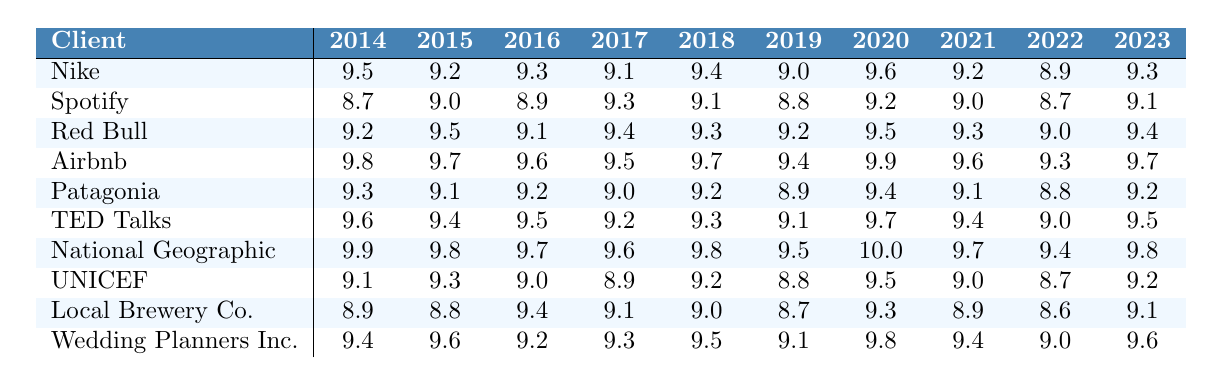What is the satisfaction rating of Nike in 2020? The table indicates that Nike's satisfaction rating for the year 2020 is 9.2, as listed in the corresponding row and column.
Answer: 9.2 What is the highest satisfaction rating recorded for National Geographic? The highest rating for National Geographic is 10.0, which can be found in the year 2019 column.
Answer: 10.0 Which client received the lowest satisfaction rating in 2015? By examining the ratings for each client in 2015, the lowest rating is 8.7, which corresponds to Spotify.
Answer: Spotify What is the average satisfaction rating of Airbnb across all years? To find the average, sum all the ratings for Airbnb (9.8 + 9.7 + 9.6 + 9.5 + 9.7 + 9.4 + 9.9 + 9.6 + 9.3 + 9.7 = 96.2) and divide by the total number of years (10). Thus, the average rating is 96.2 / 10 = 9.62.
Answer: 9.62 Did any client receive a satisfaction rating of 9.8 in 2022? Scanning through the table for the year 2022, there is no record of any client receiving a rating of 9.8; thus, the answer is no.
Answer: No Which client consistently had a satisfaction rating above 9.5 in the years 2016 and 2017? Looking at the ratings for 2016 (9.1 for Red Bull and 9.5 for Airbnb) and for 2017 (9.4 for Red Bull and 9.7 for Airbnb), we see that Airbnb is the only client that meets the criterion in both years.
Answer: Airbnb What is the difference between the highest satisfaction rating of TED Talks and the lowest in the same year? TED Talks' highest rating occurred in 2016 at 9.5, while the lowest rating was 8.8 in 2015. The difference between 9.5 and 8.8 is 0.7.
Answer: 0.7 Which client had the highest satisfaction rating in the last year (2023)? In the year 2023, the ratings show that National Geographic had the highest satisfaction rating of 9.8.
Answer: National Geographic For which year did Patagonia receive the lowest satisfaction rating? By examining Patagonia's ratings from 2014 to 2023, the lowest recorded value is 8.9 in the year 2019.
Answer: 2019 How many clients had an average satisfaction rating of 9.0 or lower based on the entire dataset? After reviewing all the satisfaction ratings across all years, only one client, TED Talks, had an average below 9.0. This average is calculated as (8.8 + 9.0 + 9.2 + 9.1 + 9.3 + 9.5 + 9.7 + 9.4 + 9.0 + 9.1 = 91.1/10 = 9.11), but since all others exceeded 9.0+ ratings in multiple years, the count remains 1.
Answer: 1 